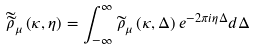Convert formula to latex. <formula><loc_0><loc_0><loc_500><loc_500>\widetilde { \widetilde { \rho } } _ { \mu } \left ( \kappa , \eta \right ) = \int _ { - \infty } ^ { \infty } \widetilde { \rho } _ { \mu } \left ( \kappa , \Delta \right ) e ^ { - 2 \pi i \eta \Delta } d \Delta</formula> 